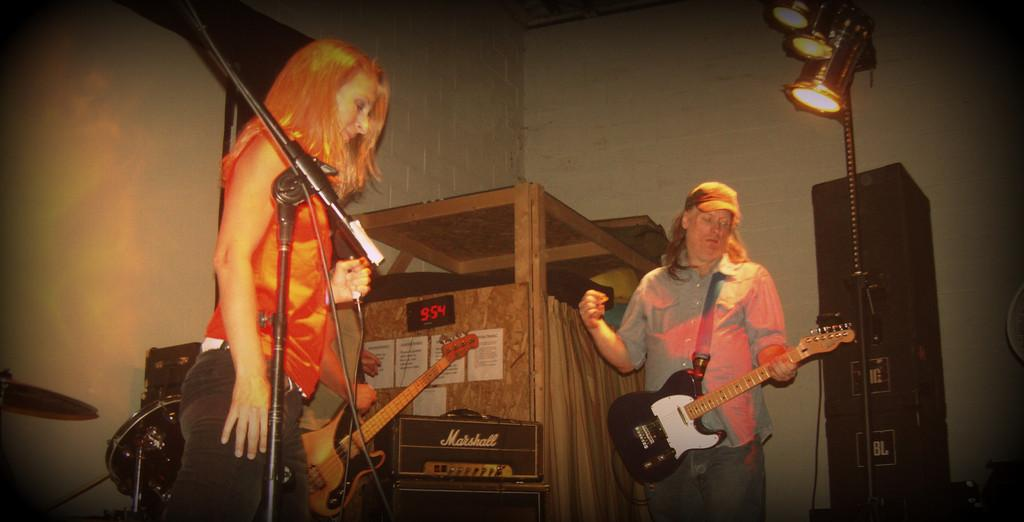What are the people in the image doing? There is a woman playing a musical instrument and a man playing a musical instrument in the image. Can you describe the woman holding a microphone? Yes, there is a woman holding a microphone in the image. What can be seen in the background of the image? There is a wooden cupboard and a wall in the background of the image. How does the alarm in the image? There is no alarm present in the image. 